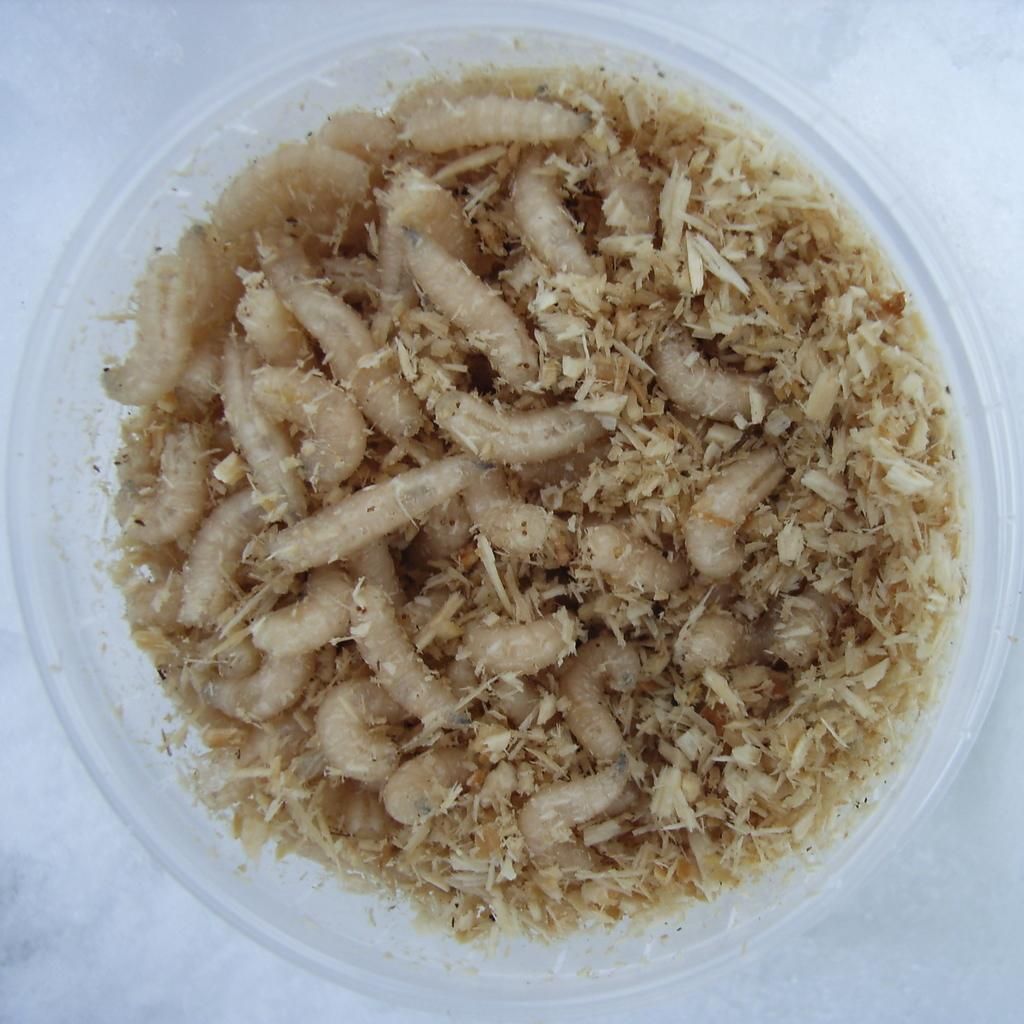What is located in the foreground of the image? There are worms in a bowl in the foreground of the image. Can you describe the contents of the bowl? The bowl contains worms. What might be the purpose of having worms in a bowl? It is unclear from the image what the purpose of having worms in a bowl might be. What type of texture can be seen on the plate in the image? There is no plate present in the image, only a bowl of worms. 